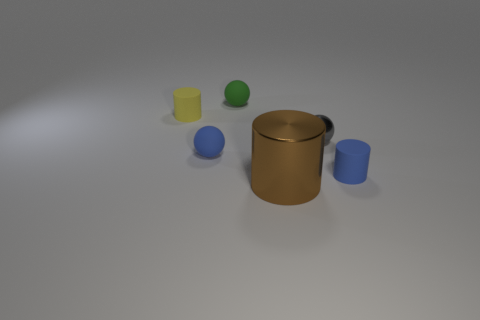How many objects are both on the right side of the green ball and behind the big brown metallic thing?
Provide a short and direct response. 2. What number of brown things are metal things or matte blocks?
Keep it short and to the point. 1. What size is the gray thing?
Make the answer very short. Small. How many matte things are yellow cubes or blue balls?
Keep it short and to the point. 1. Are there fewer tiny objects than large red cylinders?
Ensure brevity in your answer.  No. What number of other objects are there of the same material as the large thing?
Offer a very short reply. 1. There is another rubber object that is the same shape as the yellow matte object; what is its size?
Offer a very short reply. Small. Is the material of the tiny cylinder left of the small green object the same as the blue thing behind the blue cylinder?
Your answer should be very brief. Yes. Are there fewer tiny blue rubber objects that are to the right of the big thing than big objects?
Provide a short and direct response. No. There is another small rubber thing that is the same shape as the green matte object; what is its color?
Provide a succinct answer. Blue. 